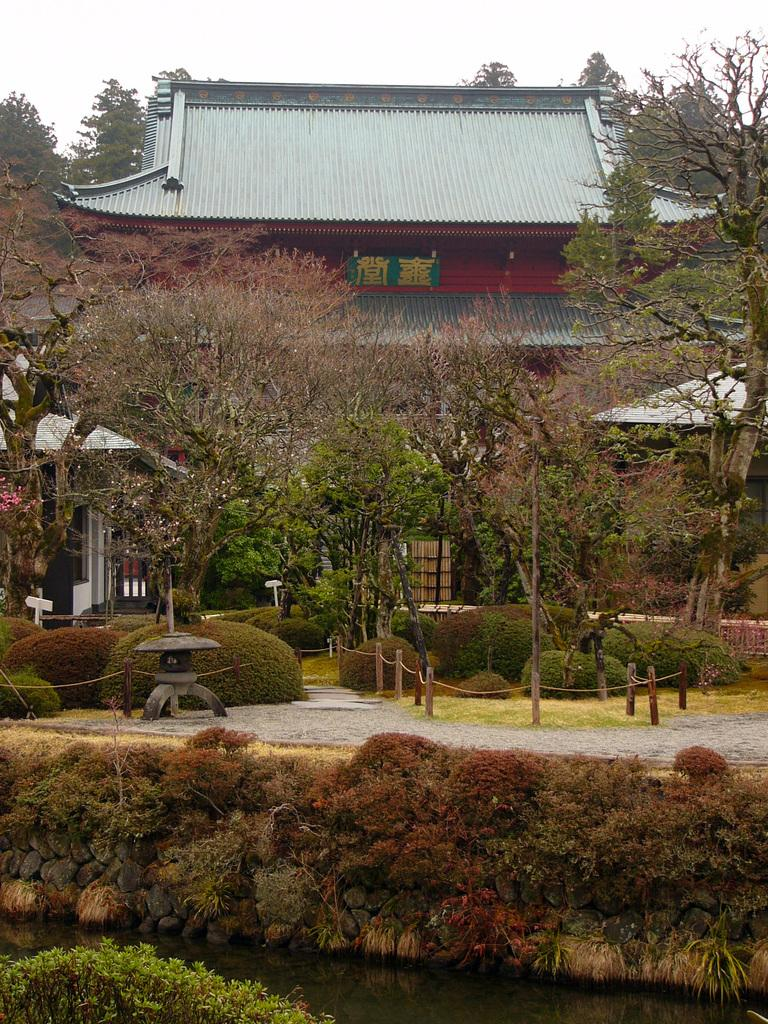What is the main structure visible in the image? There is a building in the image. What type of vegetation is present in front of the building? There are trees and plants in front of the building. Can you describe the background of the image? There are additional trees in the background of the image. What type of veil can be seen covering the mountain in the image? There is no mountain or veil present in the image. Can you describe the doll's clothing in the image? There is no doll present in the image. 